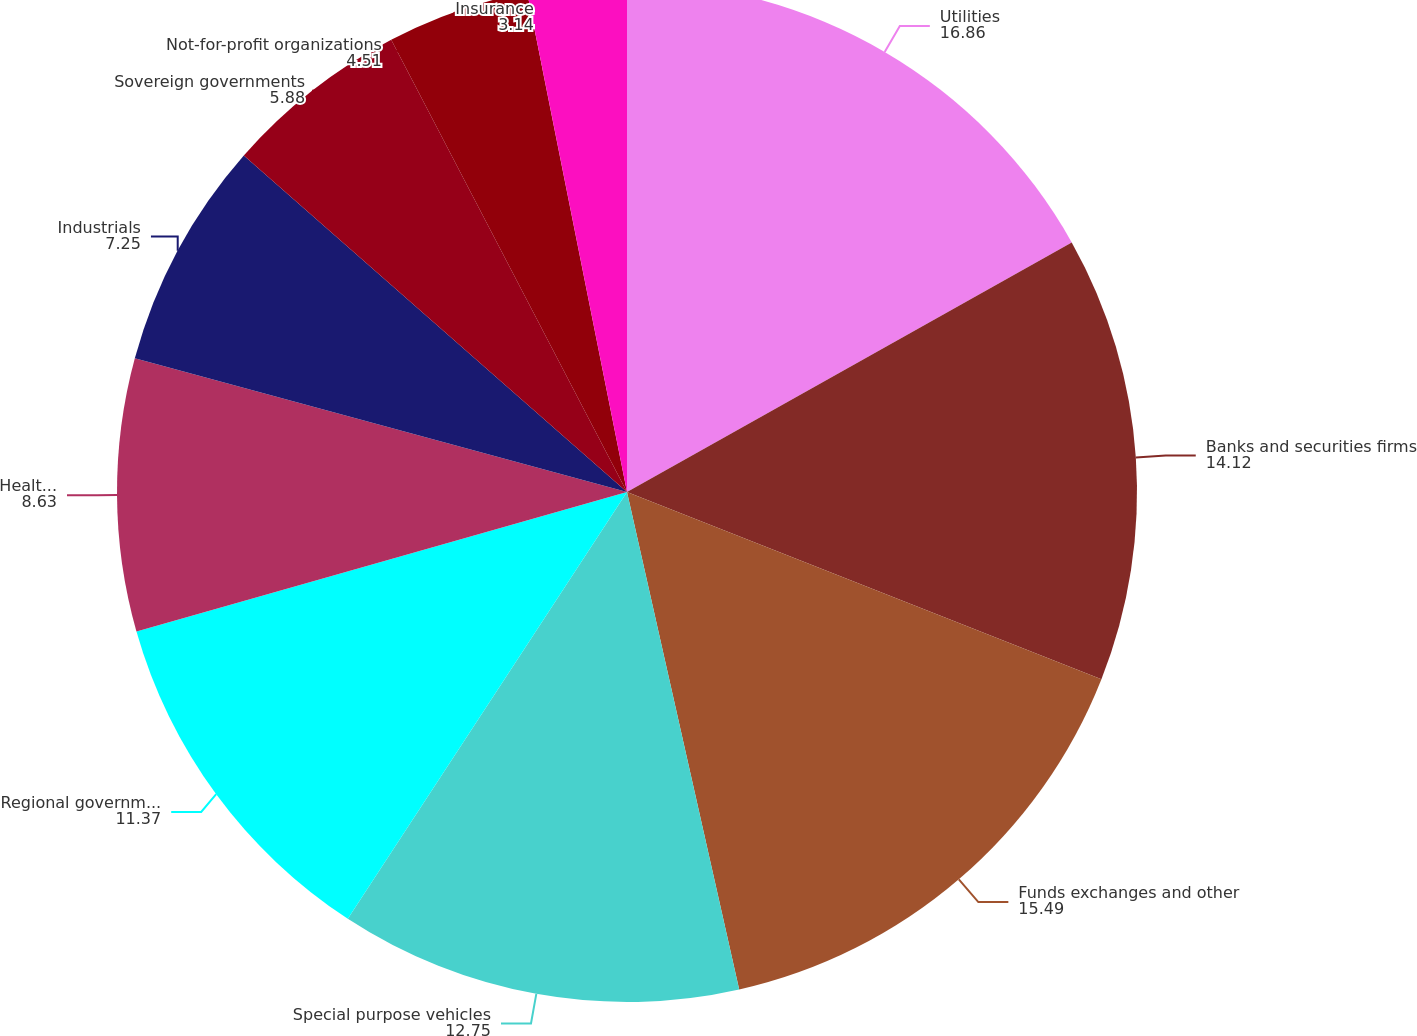<chart> <loc_0><loc_0><loc_500><loc_500><pie_chart><fcel>Utilities<fcel>Banks and securities firms<fcel>Funds exchanges and other<fcel>Special purpose vehicles<fcel>Regional governments<fcel>Healthcare<fcel>Industrials<fcel>Sovereign governments<fcel>Not-for-profit organizations<fcel>Insurance<nl><fcel>16.86%<fcel>14.12%<fcel>15.49%<fcel>12.75%<fcel>11.37%<fcel>8.63%<fcel>7.25%<fcel>5.88%<fcel>4.51%<fcel>3.14%<nl></chart> 